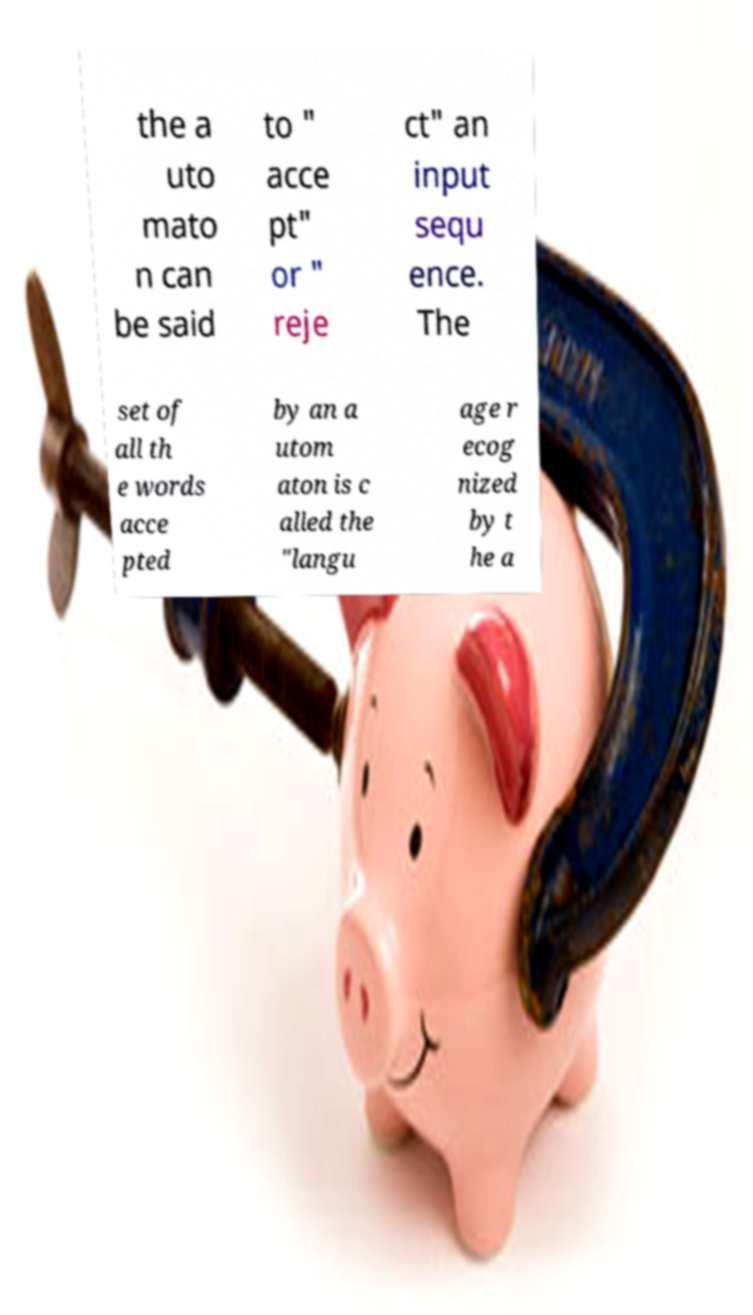What messages or text are displayed in this image? I need them in a readable, typed format. the a uto mato n can be said to " acce pt" or " reje ct" an input sequ ence. The set of all th e words acce pted by an a utom aton is c alled the "langu age r ecog nized by t he a 